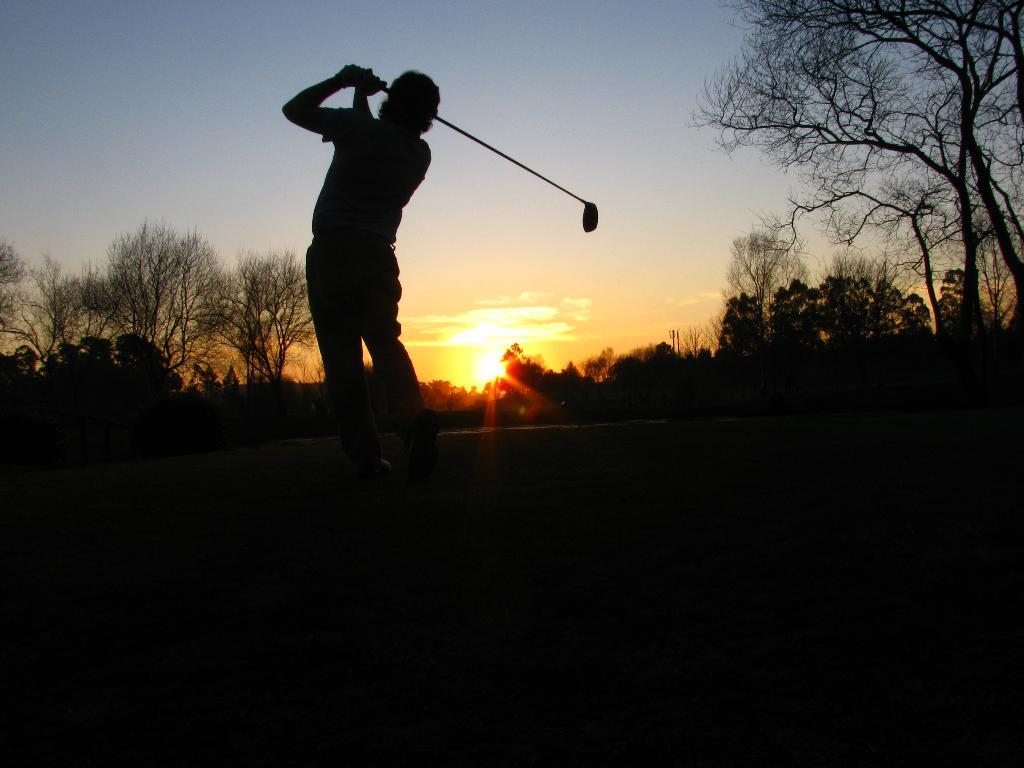What is the person in the image doing? The person is standing on the land and holding a stick in his hand. What can be seen in the background of the image? There are trees in the background of the image. What is visible at the top of the image? The sky is visible at the top of the image, and the sun is present in the sky. What type of meat can be seen hanging from the trees in the image? There is no meat present in the image; it only features a person holding a stick and trees in the background. 